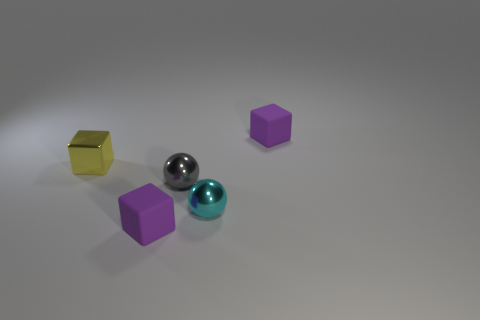Is the number of small cyan spheres that are in front of the small cyan metallic thing the same as the number of small gray things behind the yellow block? yes 